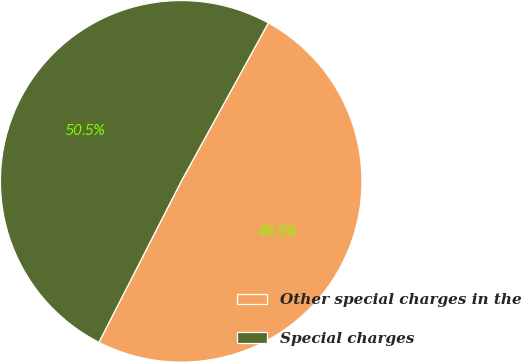Convert chart to OTSL. <chart><loc_0><loc_0><loc_500><loc_500><pie_chart><fcel>Other special charges in the<fcel>Special charges<nl><fcel>49.52%<fcel>50.48%<nl></chart> 